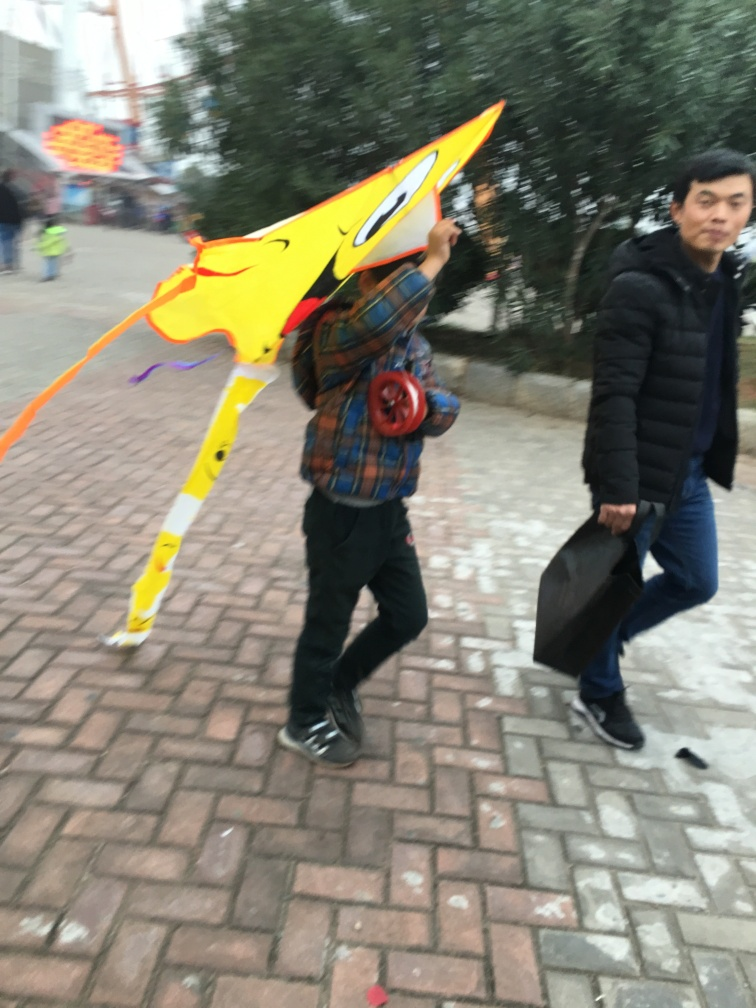Is the background blurry?
 Yes 